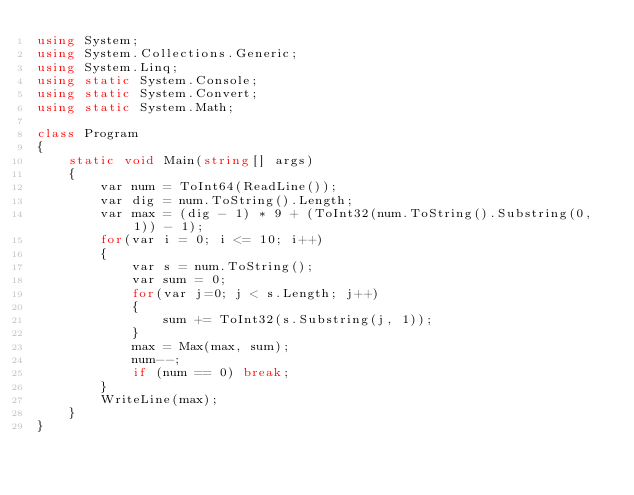Convert code to text. <code><loc_0><loc_0><loc_500><loc_500><_C#_>using System;
using System.Collections.Generic;
using System.Linq;
using static System.Console;
using static System.Convert;
using static System.Math;

class Program
{
    static void Main(string[] args)
    {
        var num = ToInt64(ReadLine());
        var dig = num.ToString().Length;
        var max = (dig - 1) * 9 + (ToInt32(num.ToString().Substring(0, 1)) - 1);
        for(var i = 0; i <= 10; i++)
        {
            var s = num.ToString();
            var sum = 0;
            for(var j=0; j < s.Length; j++)
            {
                sum += ToInt32(s.Substring(j, 1));
            }
            max = Max(max, sum);
            num--;
            if (num == 0) break;
        }
        WriteLine(max);
    }
}
</code> 